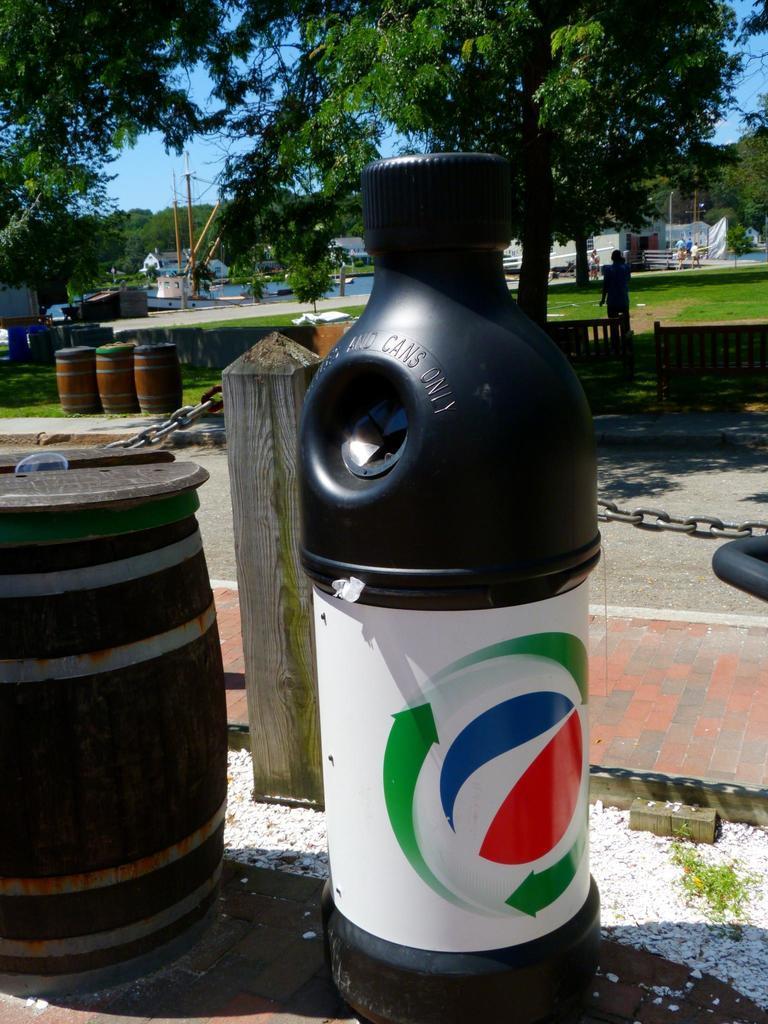Describe this image in one or two sentences. In the middle it's a bottle shaped container and there is a barrel beside of it and it there is a person and trees. 